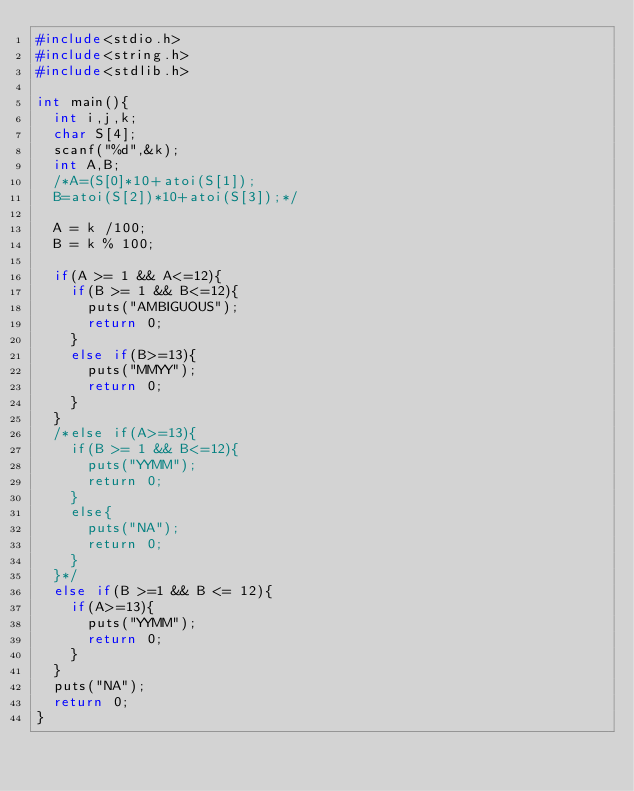<code> <loc_0><loc_0><loc_500><loc_500><_C_>#include<stdio.h>
#include<string.h>
#include<stdlib.h>

int main(){
  int i,j,k;
  char S[4];
  scanf("%d",&k);
  int A,B;
  /*A=(S[0]*10+atoi(S[1]);
  B=atoi(S[2])*10+atoi(S[3]);*/
  
  A = k /100;
  B = k % 100;
  
  if(A >= 1 && A<=12){
    if(B >= 1 && B<=12){
      puts("AMBIGUOUS");
      return 0;
    }
    else if(B>=13){
      puts("MMYY");
      return 0;
    }
  }
  /*else if(A>=13){
    if(B >= 1 && B<=12){
      puts("YYMM");
      return 0;
    }
    else{
      puts("NA");
      return 0;
    }
  }*/
  else if(B >=1 && B <= 12){
    if(A>=13){
      puts("YYMM");
      return 0;
    }
  }
  puts("NA");
  return 0;
}

</code> 